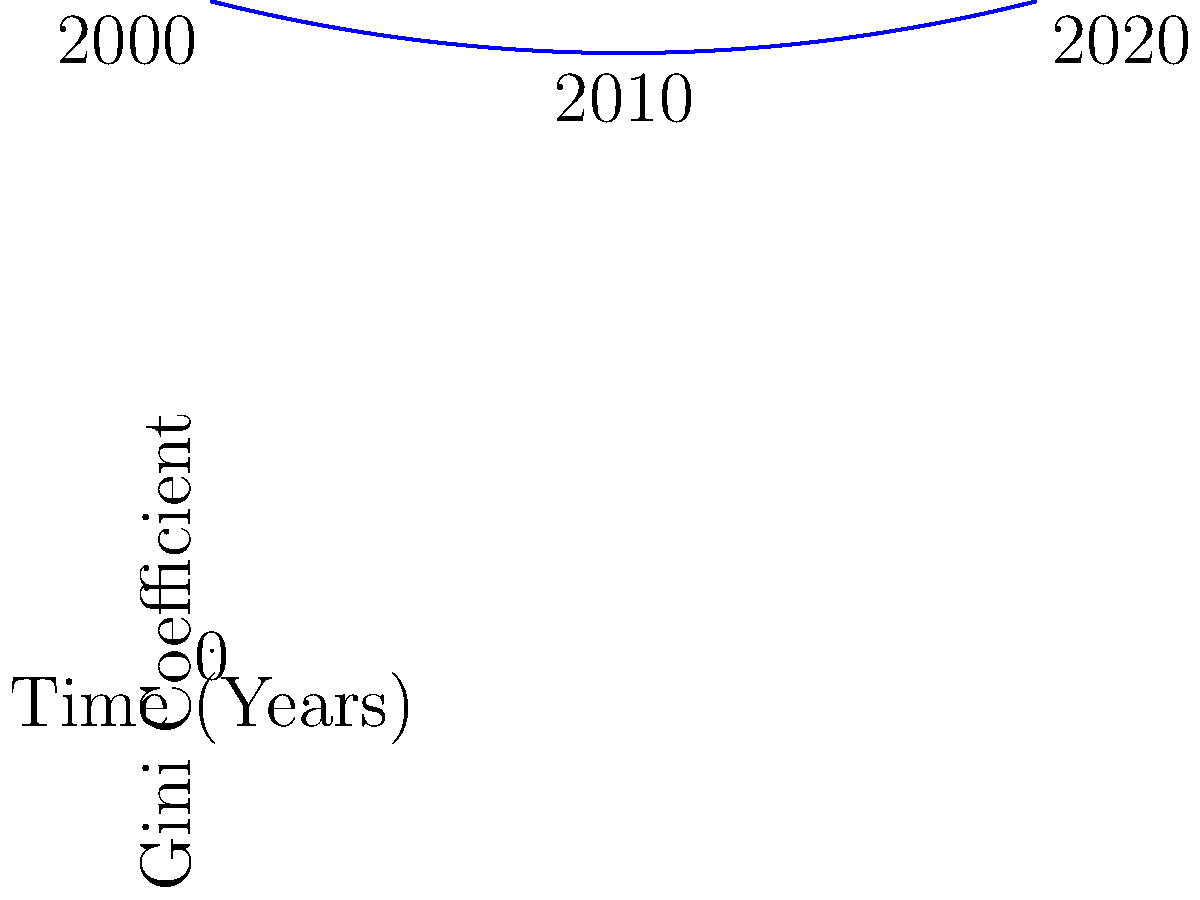As a fellow South African author writing on socio-political issues, analyze the graph depicting income inequality trends in South Africa from 2000 to 2020. What does the shape of the curve suggest about the effectiveness of post-apartheid economic policies in addressing income inequality? To analyze the graph and its implications for post-apartheid economic policies:

1. Observe the initial Gini coefficient: In 2000, the Gini coefficient is approximately 0.63, indicating high income inequality.

2. Note the trend from 2000 to 2010: The curve shows a slight decrease in the Gini coefficient, suggesting a marginal improvement in income equality during this period.

3. Examine the trend from 2010 to 2020: The curve begins to rise again, indicating a reversal of the initial progress and a widening of income inequality.

4. Calculate the overall change: The Gini coefficient at the end of the period (2020) is slightly higher than at the beginning (2000), showing a net increase in inequality over 20 years.

5. Interpret the curve's shape: The U-shaped curve suggests that initial post-apartheid policies may have had some positive impact on reducing inequality, but this effect was not sustained in the long term.

6. Consider policy implications: The reversal of progress after 2010 indicates that more recent economic policies have been less effective in addressing income inequality, or that other factors have counteracted their impact.

7. Reflect on the persistence of inequality: The consistently high Gini coefficient throughout the period (above 0.6) suggests that deep-rooted structural inequalities from the apartheid era have proven difficult to overcome.
Answer: The U-shaped curve indicates initial progress in reducing inequality was not sustained, suggesting limited long-term effectiveness of post-apartheid economic policies in addressing income disparity. 